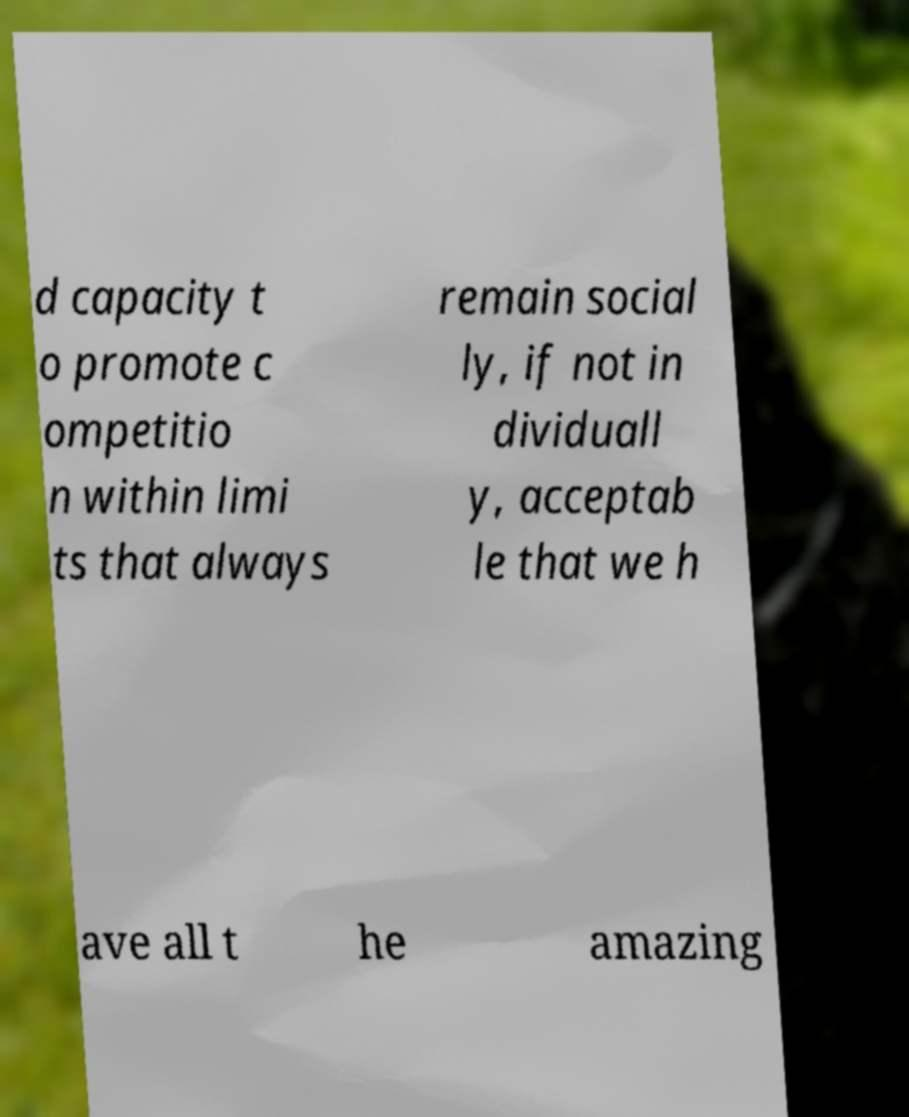What messages or text are displayed in this image? I need them in a readable, typed format. d capacity t o promote c ompetitio n within limi ts that always remain social ly, if not in dividuall y, acceptab le that we h ave all t he amazing 